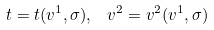Convert formula to latex. <formula><loc_0><loc_0><loc_500><loc_500>t = t ( v ^ { 1 } , \sigma ) , \ \, v ^ { 2 } = v ^ { 2 } ( v ^ { 1 } , \sigma )</formula> 